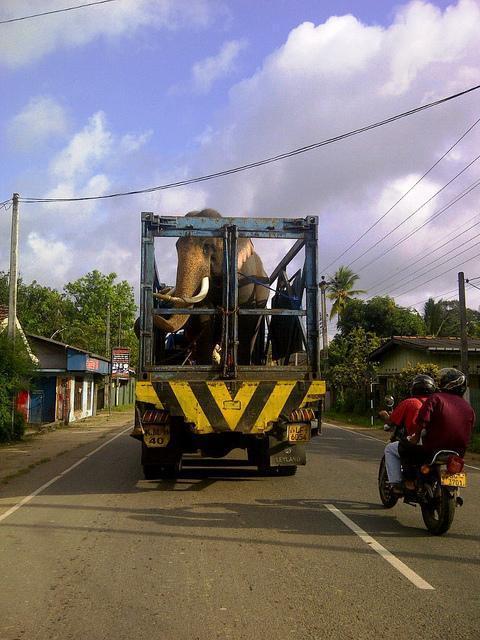How many elephants can be seen?
Give a very brief answer. 1. How many windows on this bus face toward the traffic behind it?
Give a very brief answer. 0. 